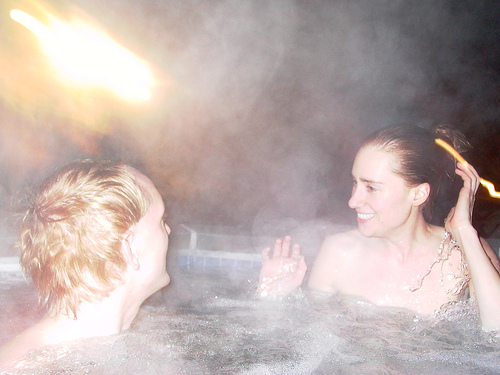<image>
Is there a women next to the men? Yes. The women is positioned adjacent to the men, located nearby in the same general area. 